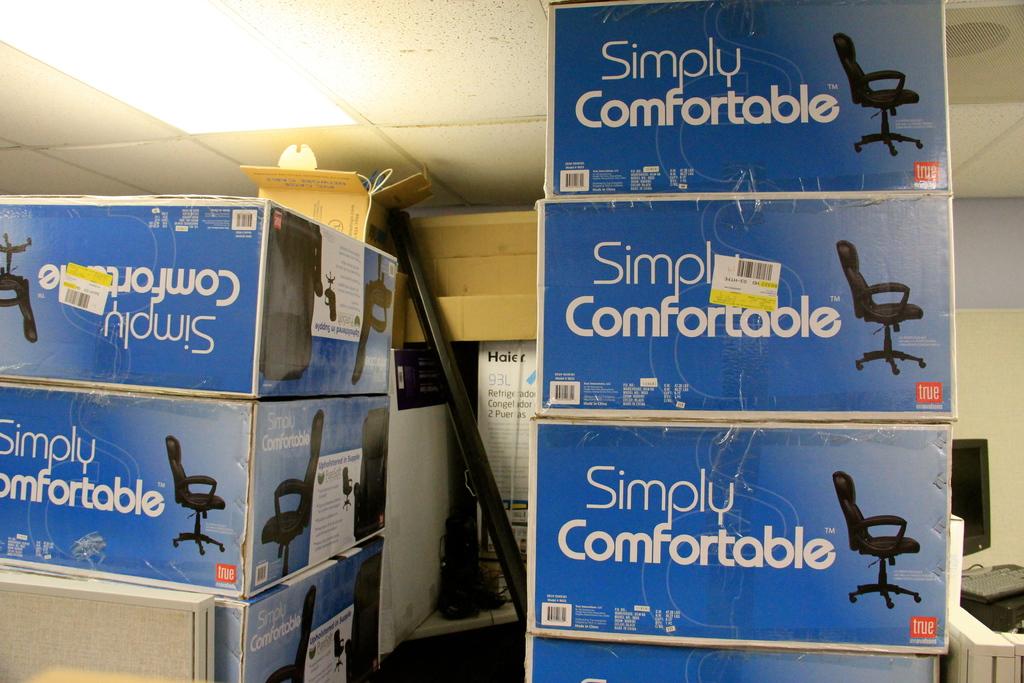What is the name of this chair?
Make the answer very short. Simply comfortable. What does the text in the orange box say?
Give a very brief answer. True. 